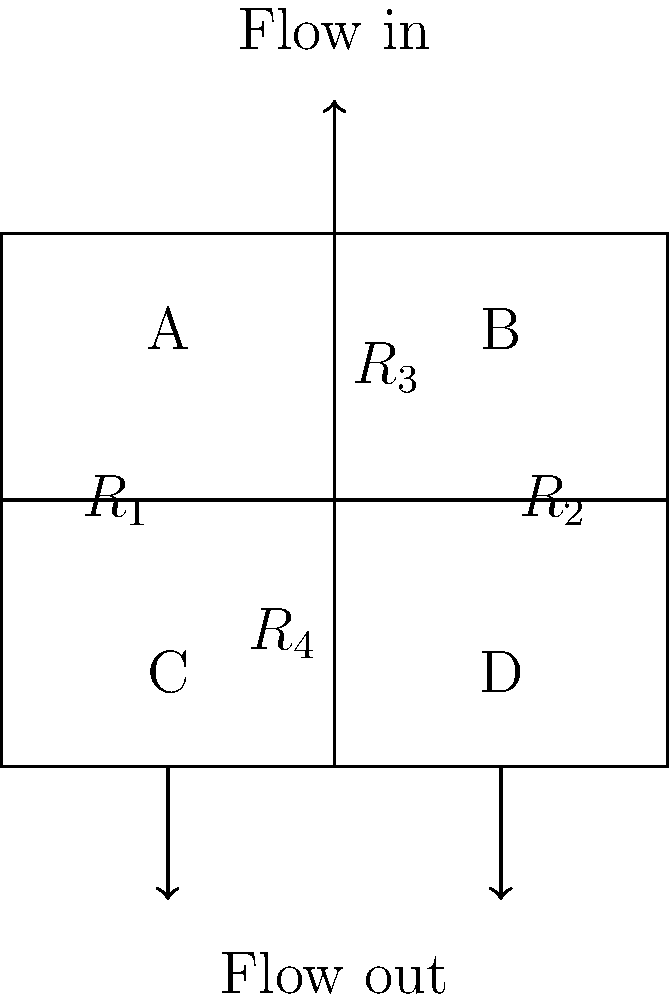In a complex pipe network, fluid enters at the top and exits through two outlets at the bottom, as shown in the diagram. The network is divided into four sections with resistances $R_1$, $R_2$, $R_3$, and $R_4$. Given that the total flow rate is 100 L/min and the pressure drop across the entire system is 500 kPa, determine the optimal distribution of resistances to minimize power loss in the system. Assume laminar flow and that power loss is proportional to the square of the flow rate through each section. To minimize power loss in the system, we need to follow these steps:

1) First, let's understand that the power loss in a pipe section is given by:
   $P = Q^2R$, where $Q$ is the flow rate and $R$ is the resistance.

2) The total power loss in the system is the sum of power losses in each section:
   $P_{total} = Q_1^2R_1 + Q_2^2R_2 + Q_3^2R_3 + Q_4^2R_4$

3) We have two constraints:
   a) Total flow: $Q_1 + Q_2 = Q_3 + Q_4 = 100$ L/min
   b) Pressure drop: $Q_1R_1 + Q_3R_3 = Q_2R_2 + Q_4R_4 = 500$ kPa

4) To minimize power loss, we need equal power loss in each parallel path:
   $Q_1^2R_1 + Q_3^2R_3 = Q_2^2R_2 + Q_4^2R_4$

5) Given the symmetry of the problem, the optimal solution will have:
   $Q_1 = Q_2 = Q_3 = Q_4 = 50$ L/min

6) Substituting this into the pressure drop equation:
   $50R_1 + 50R_3 = 50R_2 + 50R_4 = 500$ kPa
   $R_1 + R_3 = R_2 + R_4 = 10$ kPa/(L/min)

7) To minimize power loss, we want:
   $R_1 = R_2$ and $R_3 = R_4$

8) Therefore, the optimal distribution is:
   $R_1 = R_2 = 5$ kPa/(L/min)
   $R_3 = R_4 = 5$ kPa/(L/min)

This distribution ensures equal flow through all paths and equal pressure drops, minimizing the overall power loss in the system.
Answer: $R_1 = R_2 = R_3 = R_4 = 5$ kPa/(L/min) 